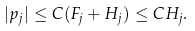<formula> <loc_0><loc_0><loc_500><loc_500>| p _ { j } | \leq C ( F _ { j } + H _ { j } ) \leq C H _ { j } .</formula> 